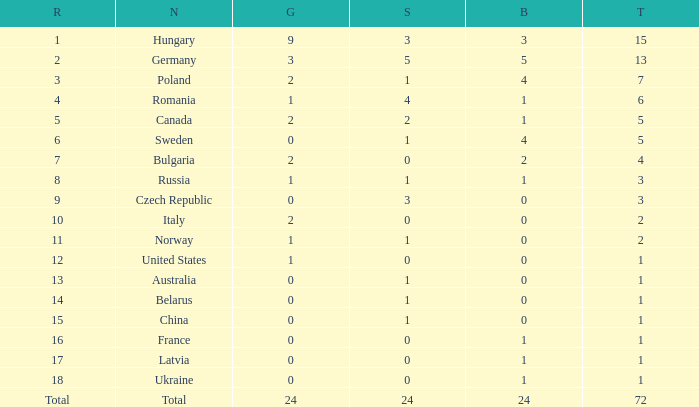What nation has 0 as the silver, 1 as the bronze, with 18 as the rank? Ukraine. 